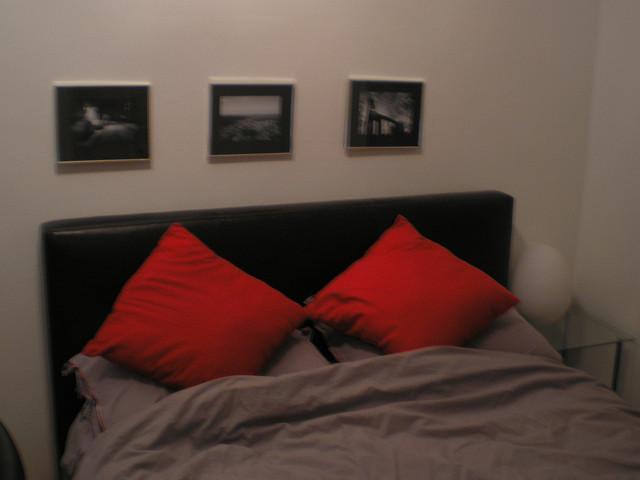How many pictures are on the wall?
Give a very brief answer. 3. 